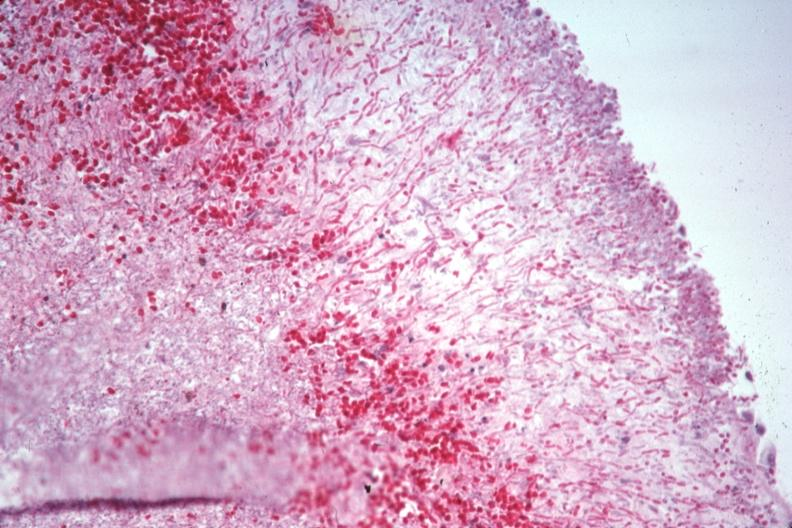s hematologic present?
Answer the question using a single word or phrase. Yes 